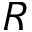<formula> <loc_0><loc_0><loc_500><loc_500>R</formula> 